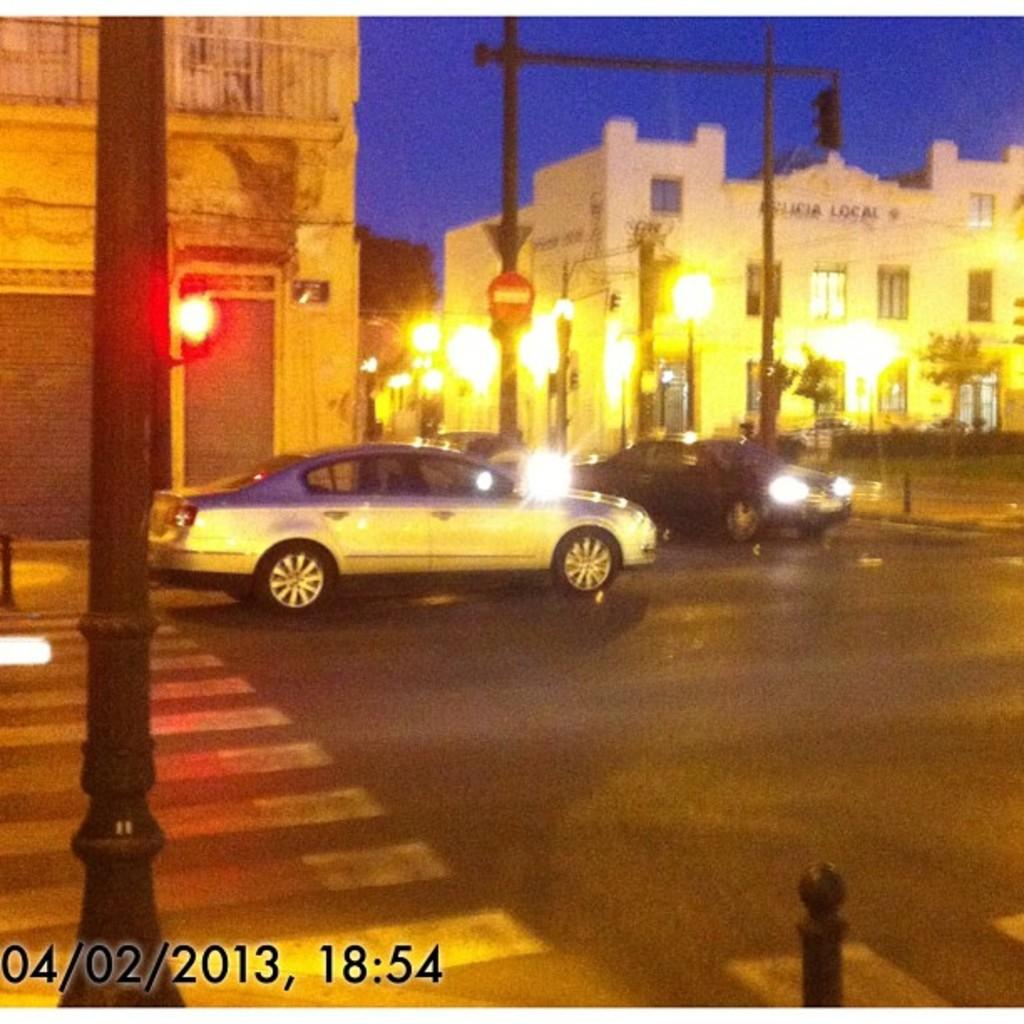<image>
Provide a brief description of the given image. Two cars are at an intersection on April second, 2013, at 6:54. 